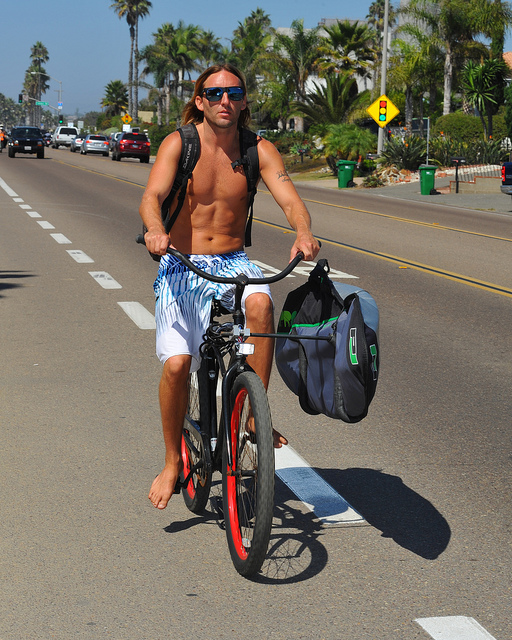<image>What type of footwear is the man wearing? The man is not wearing any type of footwear. What type of footwear is the man wearing? The man is not wearing any footwear. 